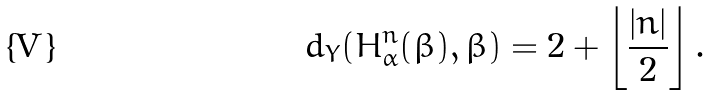Convert formula to latex. <formula><loc_0><loc_0><loc_500><loc_500>d _ { Y } ( H ^ { n } _ { \alpha } ( \beta ) , \beta ) = 2 + \left \lfloor \frac { | n | } { 2 } \right \rfloor .</formula> 